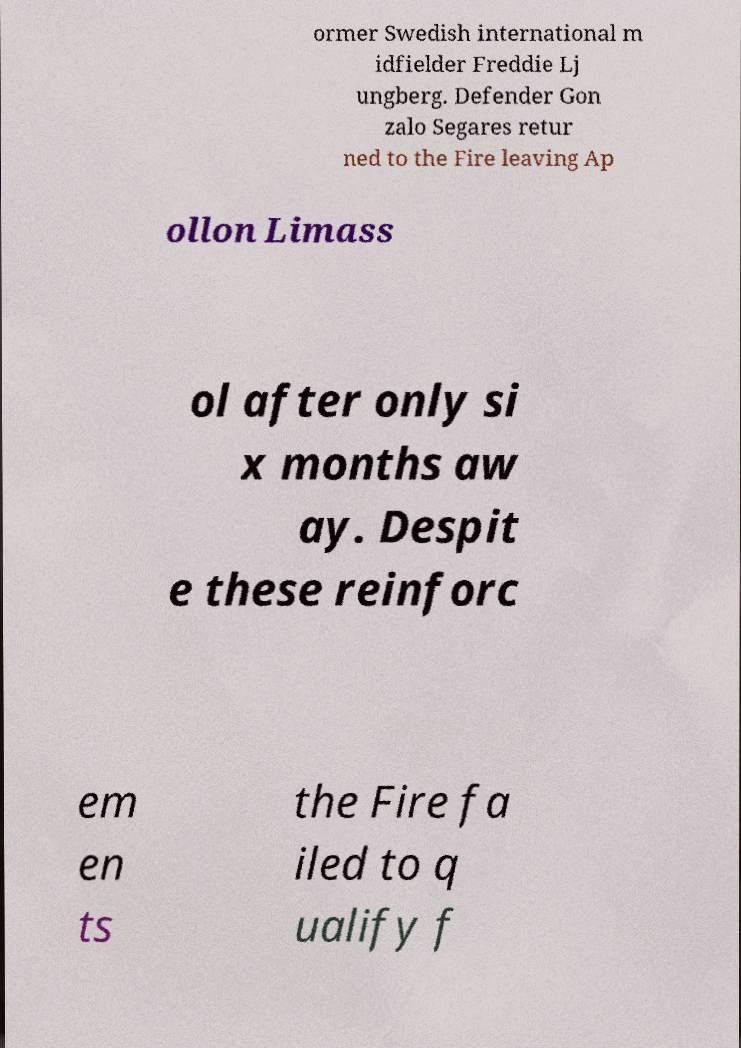I need the written content from this picture converted into text. Can you do that? ormer Swedish international m idfielder Freddie Lj ungberg. Defender Gon zalo Segares retur ned to the Fire leaving Ap ollon Limass ol after only si x months aw ay. Despit e these reinforc em en ts the Fire fa iled to q ualify f 